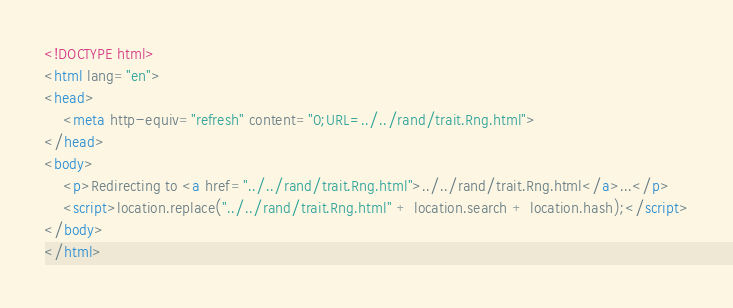<code> <loc_0><loc_0><loc_500><loc_500><_HTML_><!DOCTYPE html>
<html lang="en">
<head>
    <meta http-equiv="refresh" content="0;URL=../../rand/trait.Rng.html">
</head>
<body>
    <p>Redirecting to <a href="../../rand/trait.Rng.html">../../rand/trait.Rng.html</a>...</p>
    <script>location.replace("../../rand/trait.Rng.html" + location.search + location.hash);</script>
</body>
</html></code> 